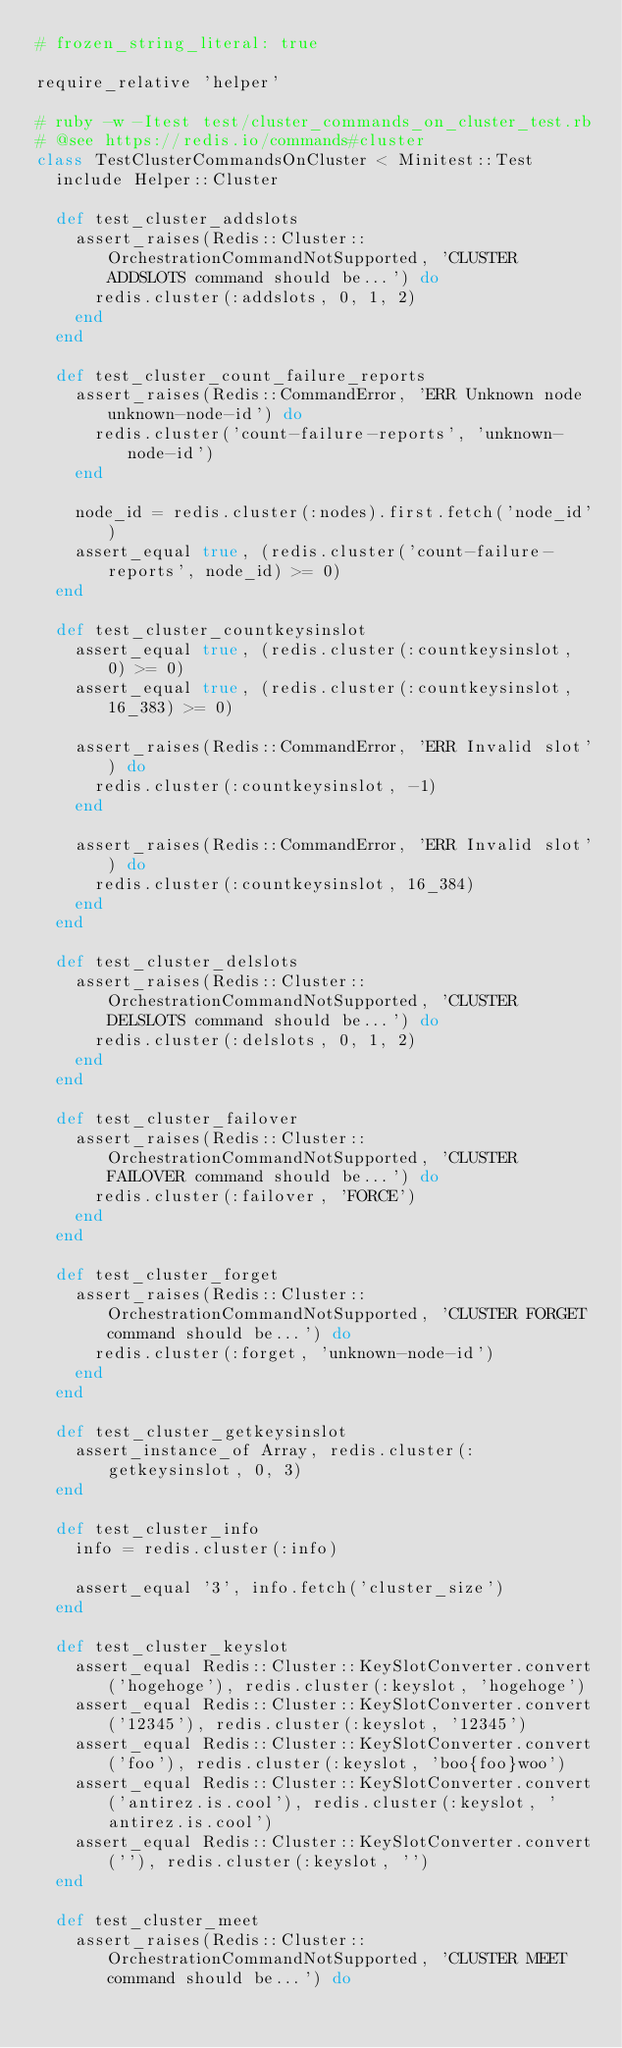<code> <loc_0><loc_0><loc_500><loc_500><_Ruby_># frozen_string_literal: true

require_relative 'helper'

# ruby -w -Itest test/cluster_commands_on_cluster_test.rb
# @see https://redis.io/commands#cluster
class TestClusterCommandsOnCluster < Minitest::Test
  include Helper::Cluster

  def test_cluster_addslots
    assert_raises(Redis::Cluster::OrchestrationCommandNotSupported, 'CLUSTER ADDSLOTS command should be...') do
      redis.cluster(:addslots, 0, 1, 2)
    end
  end

  def test_cluster_count_failure_reports
    assert_raises(Redis::CommandError, 'ERR Unknown node unknown-node-id') do
      redis.cluster('count-failure-reports', 'unknown-node-id')
    end

    node_id = redis.cluster(:nodes).first.fetch('node_id')
    assert_equal true, (redis.cluster('count-failure-reports', node_id) >= 0)
  end

  def test_cluster_countkeysinslot
    assert_equal true, (redis.cluster(:countkeysinslot, 0) >= 0)
    assert_equal true, (redis.cluster(:countkeysinslot, 16_383) >= 0)

    assert_raises(Redis::CommandError, 'ERR Invalid slot') do
      redis.cluster(:countkeysinslot, -1)
    end

    assert_raises(Redis::CommandError, 'ERR Invalid slot') do
      redis.cluster(:countkeysinslot, 16_384)
    end
  end

  def test_cluster_delslots
    assert_raises(Redis::Cluster::OrchestrationCommandNotSupported, 'CLUSTER DELSLOTS command should be...') do
      redis.cluster(:delslots, 0, 1, 2)
    end
  end

  def test_cluster_failover
    assert_raises(Redis::Cluster::OrchestrationCommandNotSupported, 'CLUSTER FAILOVER command should be...') do
      redis.cluster(:failover, 'FORCE')
    end
  end

  def test_cluster_forget
    assert_raises(Redis::Cluster::OrchestrationCommandNotSupported, 'CLUSTER FORGET command should be...') do
      redis.cluster(:forget, 'unknown-node-id')
    end
  end

  def test_cluster_getkeysinslot
    assert_instance_of Array, redis.cluster(:getkeysinslot, 0, 3)
  end

  def test_cluster_info
    info = redis.cluster(:info)

    assert_equal '3', info.fetch('cluster_size')
  end

  def test_cluster_keyslot
    assert_equal Redis::Cluster::KeySlotConverter.convert('hogehoge'), redis.cluster(:keyslot, 'hogehoge')
    assert_equal Redis::Cluster::KeySlotConverter.convert('12345'), redis.cluster(:keyslot, '12345')
    assert_equal Redis::Cluster::KeySlotConverter.convert('foo'), redis.cluster(:keyslot, 'boo{foo}woo')
    assert_equal Redis::Cluster::KeySlotConverter.convert('antirez.is.cool'), redis.cluster(:keyslot, 'antirez.is.cool')
    assert_equal Redis::Cluster::KeySlotConverter.convert(''), redis.cluster(:keyslot, '')
  end

  def test_cluster_meet
    assert_raises(Redis::Cluster::OrchestrationCommandNotSupported, 'CLUSTER MEET command should be...') do</code> 